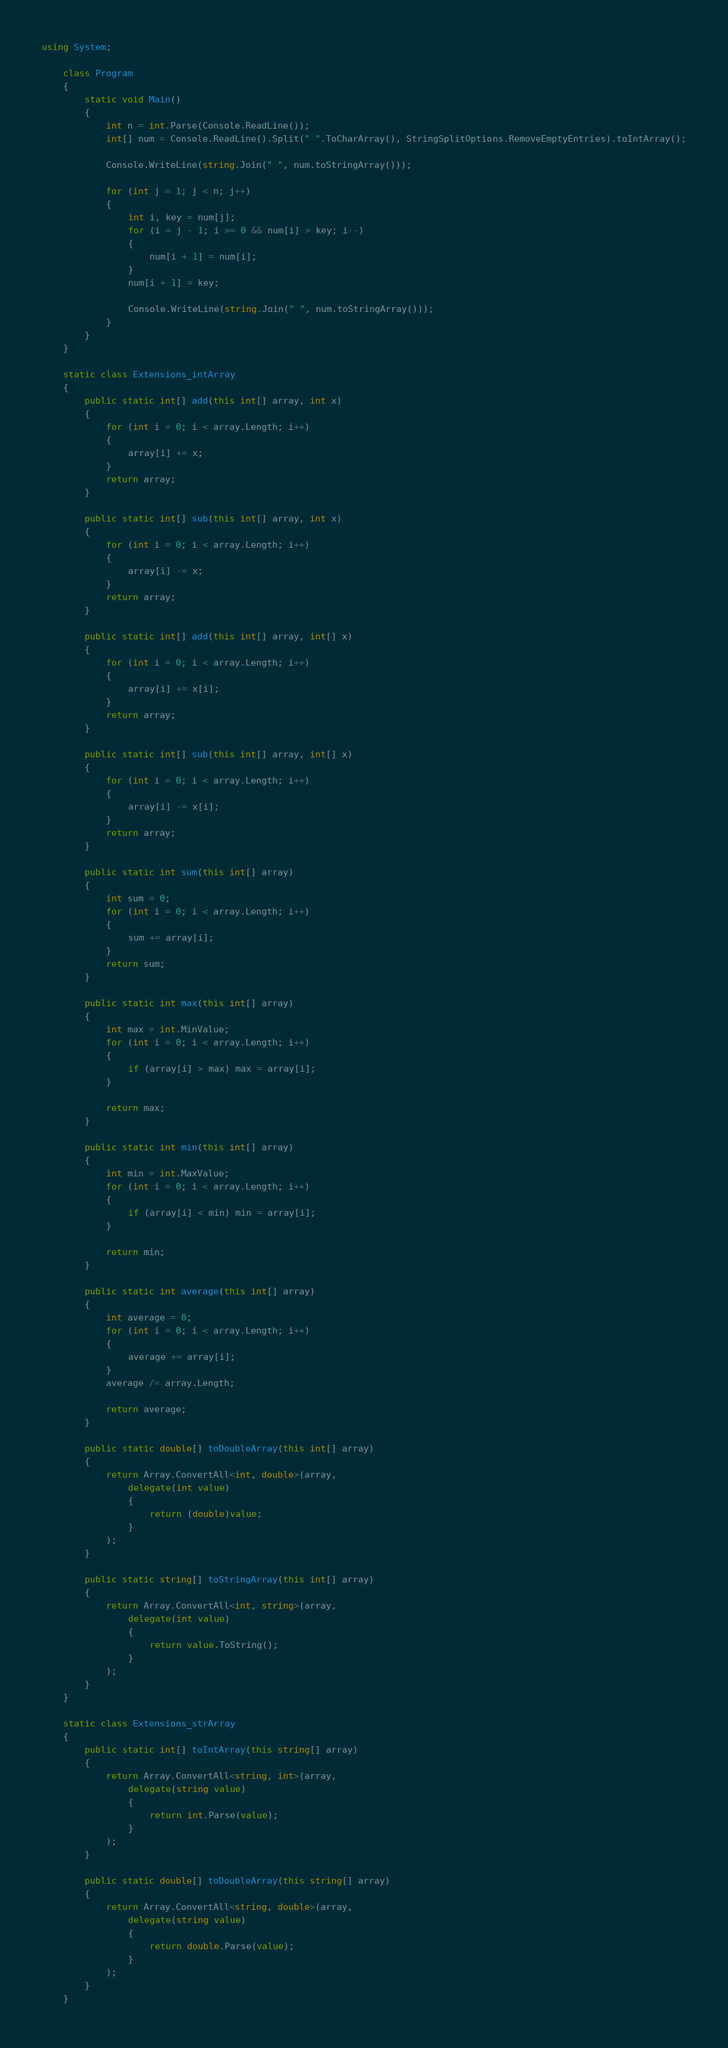Convert code to text. <code><loc_0><loc_0><loc_500><loc_500><_C#_>using System;
 
    class Program
    {
        static void Main()
        {
            int n = int.Parse(Console.ReadLine());
            int[] num = Console.ReadLine().Split(" ".ToCharArray(), StringSplitOptions.RemoveEmptyEntries).toIntArray();
 
            Console.WriteLine(string.Join(" ", num.toStringArray()));

            for (int j = 1; j < n; j++)
            {
                int i, key = num[j];
                for (i = j - 1; i >= 0 && num[i] > key; i--)
                {
                    num[i + 1] = num[i];
                }
                num[i + 1] = key;
 
                Console.WriteLine(string.Join(" ", num.toStringArray()));
            }
        }
    }
 
    static class Extensions_intArray
    {
        public static int[] add(this int[] array, int x)
        {
            for (int i = 0; i < array.Length; i++)
            {
                array[i] += x;
            }
            return array;
        }
 
        public static int[] sub(this int[] array, int x)
        {
            for (int i = 0; i < array.Length; i++)
            {
                array[i] -= x;
            }
            return array;
        }
 
        public static int[] add(this int[] array, int[] x)
        {
            for (int i = 0; i < array.Length; i++)
            {
                array[i] += x[i];
            }
            return array;
        }
 
        public static int[] sub(this int[] array, int[] x)
        {
            for (int i = 0; i < array.Length; i++)
            {
                array[i] -= x[i];
            }
            return array;
        }
 
        public static int sum(this int[] array)
        {
            int sum = 0;
            for (int i = 0; i < array.Length; i++)
            {
                sum += array[i];
            }
            return sum;
        }
 
        public static int max(this int[] array)
        {
            int max = int.MinValue;
            for (int i = 0; i < array.Length; i++)
            {
                if (array[i] > max) max = array[i];
            }
 
            return max;
        }
 
        public static int min(this int[] array)
        {
            int min = int.MaxValue;
            for (int i = 0; i < array.Length; i++)
            {
                if (array[i] < min) min = array[i];
            }
 
            return min;
        }
 
        public static int average(this int[] array)
        {
            int average = 0;
            for (int i = 0; i < array.Length; i++)
            {
                average += array[i];
            }
            average /= array.Length;
 
            return average;
        }
 
        public static double[] toDoubleArray(this int[] array)
        {
            return Array.ConvertAll<int, double>(array,
                delegate(int value)
                {
                    return (double)value;
                }
            );
        }
 
        public static string[] toStringArray(this int[] array)
        {
            return Array.ConvertAll<int, string>(array,
                delegate(int value)
                {
                    return value.ToString();
                }
            );
        }
    }
 
    static class Extensions_strArray
    {
        public static int[] toIntArray(this string[] array)
        {
            return Array.ConvertAll<string, int>(array,
                delegate(string value)
                {
                    return int.Parse(value);
                }
            );
        }
 
        public static double[] toDoubleArray(this string[] array)
        {
            return Array.ConvertAll<string, double>(array,
                delegate(string value)
                {
                    return double.Parse(value);
                }
            );
        }
    }</code> 